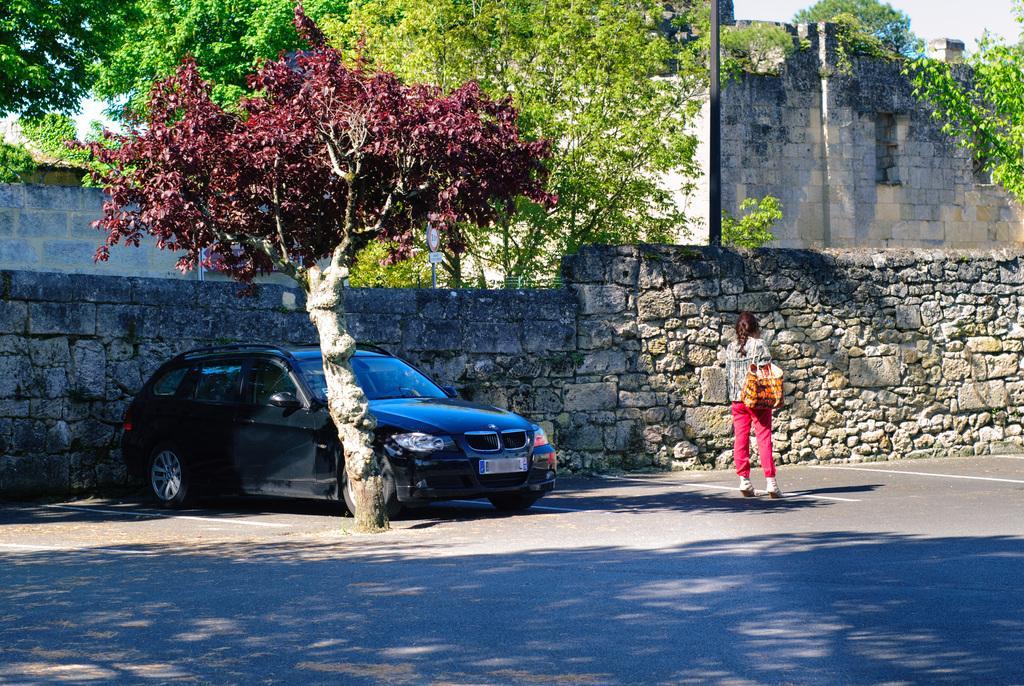Describe this image in one or two sentences. In this image we can see a girl is standing on the road. She is wearing pink color pant, grey pant and holding bag. We can see one tree. Behind the tree, car is there. Behind the car boundary wall is present. Behind the wall, trees and buildings are there. 